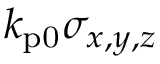Convert formula to latex. <formula><loc_0><loc_0><loc_500><loc_500>k _ { p 0 } \sigma _ { x , y , z }</formula> 